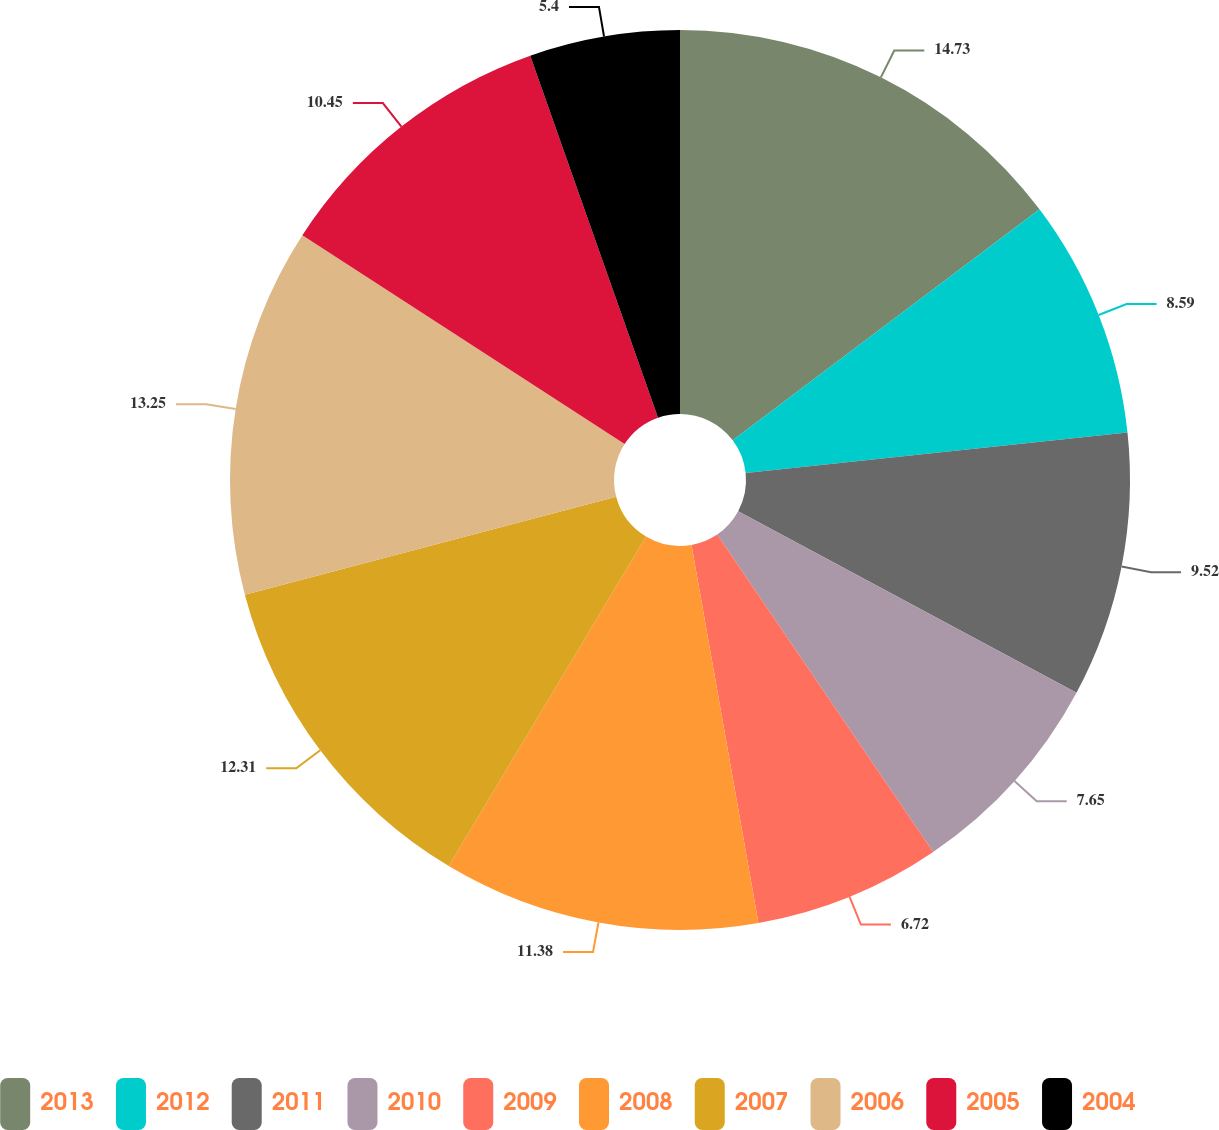Convert chart to OTSL. <chart><loc_0><loc_0><loc_500><loc_500><pie_chart><fcel>2013<fcel>2012<fcel>2011<fcel>2010<fcel>2009<fcel>2008<fcel>2007<fcel>2006<fcel>2005<fcel>2004<nl><fcel>14.73%<fcel>8.59%<fcel>9.52%<fcel>7.65%<fcel>6.72%<fcel>11.38%<fcel>12.31%<fcel>13.25%<fcel>10.45%<fcel>5.4%<nl></chart> 